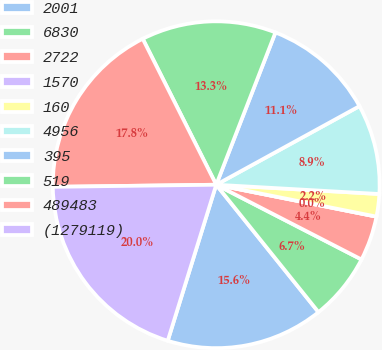Convert chart. <chart><loc_0><loc_0><loc_500><loc_500><pie_chart><fcel>2001<fcel>6830<fcel>2722<fcel>1570<fcel>160<fcel>4956<fcel>395<fcel>519<fcel>489483<fcel>(1279119)<nl><fcel>15.56%<fcel>6.67%<fcel>4.44%<fcel>0.0%<fcel>2.22%<fcel>8.89%<fcel>11.11%<fcel>13.33%<fcel>17.78%<fcel>20.0%<nl></chart> 